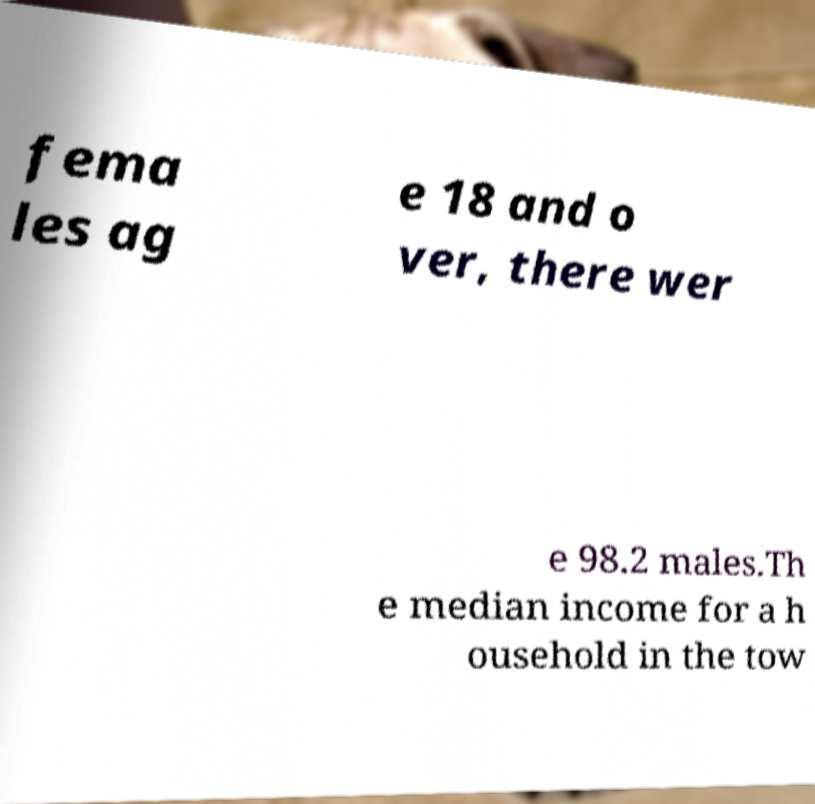Please read and relay the text visible in this image. What does it say? fema les ag e 18 and o ver, there wer e 98.2 males.Th e median income for a h ousehold in the tow 